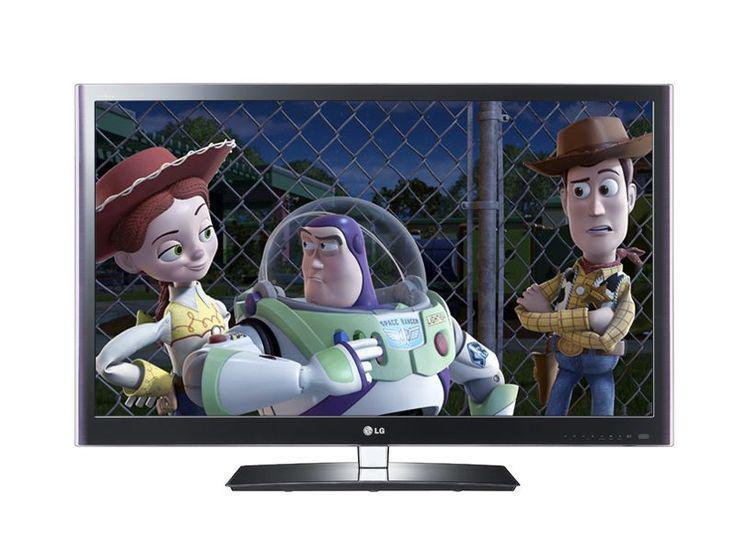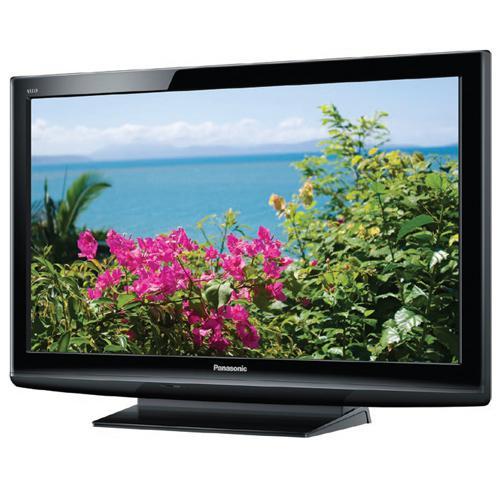The first image is the image on the left, the second image is the image on the right. Assess this claim about the two images: "A TV shows picture quality by displaying a picture of pink flowers beneath sky with clouds.". Correct or not? Answer yes or no. Yes. The first image is the image on the left, the second image is the image on the right. Analyze the images presented: Is the assertion "One of the TVs has flowers on the display." valid? Answer yes or no. Yes. 